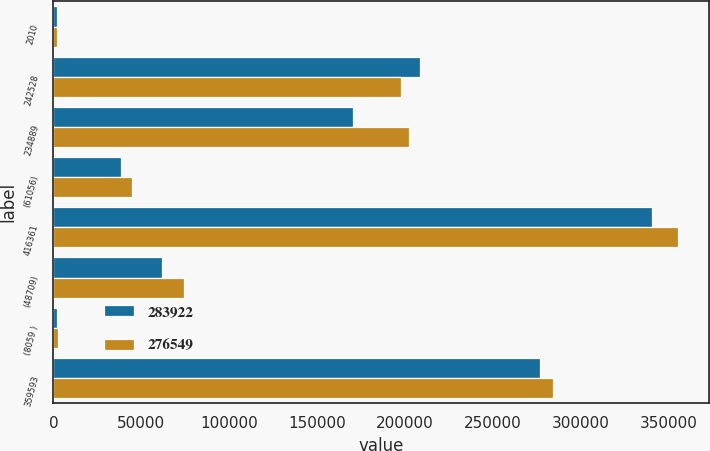Convert chart. <chart><loc_0><loc_0><loc_500><loc_500><stacked_bar_chart><ecel><fcel>2010<fcel>242528<fcel>234889<fcel>(61056)<fcel>416361<fcel>(48709)<fcel>(8059 )<fcel>359593<nl><fcel>283922<fcel>2009<fcel>208329<fcel>170515<fcel>38556<fcel>340288<fcel>61818<fcel>1921<fcel>276549<nl><fcel>276549<fcel>2008<fcel>197838<fcel>202081<fcel>44786<fcel>355133<fcel>74008<fcel>2797<fcel>283922<nl></chart> 